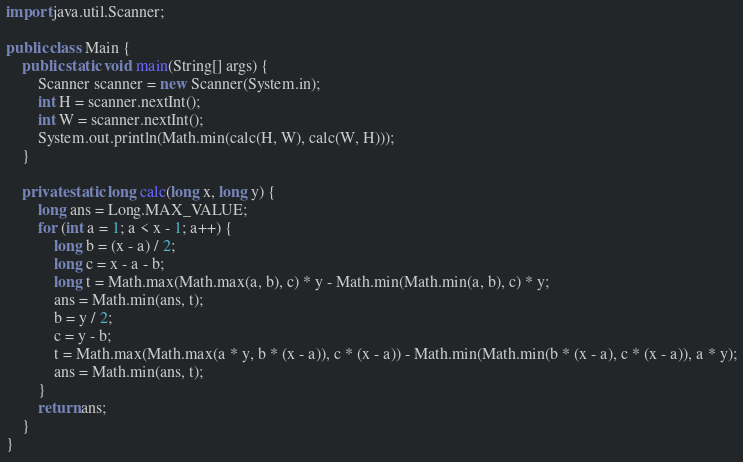Convert code to text. <code><loc_0><loc_0><loc_500><loc_500><_Java_>import java.util.Scanner;

public class Main {
    public static void main(String[] args) {
        Scanner scanner = new Scanner(System.in);
        int H = scanner.nextInt();
        int W = scanner.nextInt();
        System.out.println(Math.min(calc(H, W), calc(W, H)));
    }

    private static long calc(long x, long y) {
        long ans = Long.MAX_VALUE;
        for (int a = 1; a < x - 1; a++) {
            long b = (x - a) / 2;
            long c = x - a - b;
            long t = Math.max(Math.max(a, b), c) * y - Math.min(Math.min(a, b), c) * y;
            ans = Math.min(ans, t);
            b = y / 2;
            c = y - b;
            t = Math.max(Math.max(a * y, b * (x - a)), c * (x - a)) - Math.min(Math.min(b * (x - a), c * (x - a)), a * y);
            ans = Math.min(ans, t);
        }
        return ans;
    }
}
</code> 